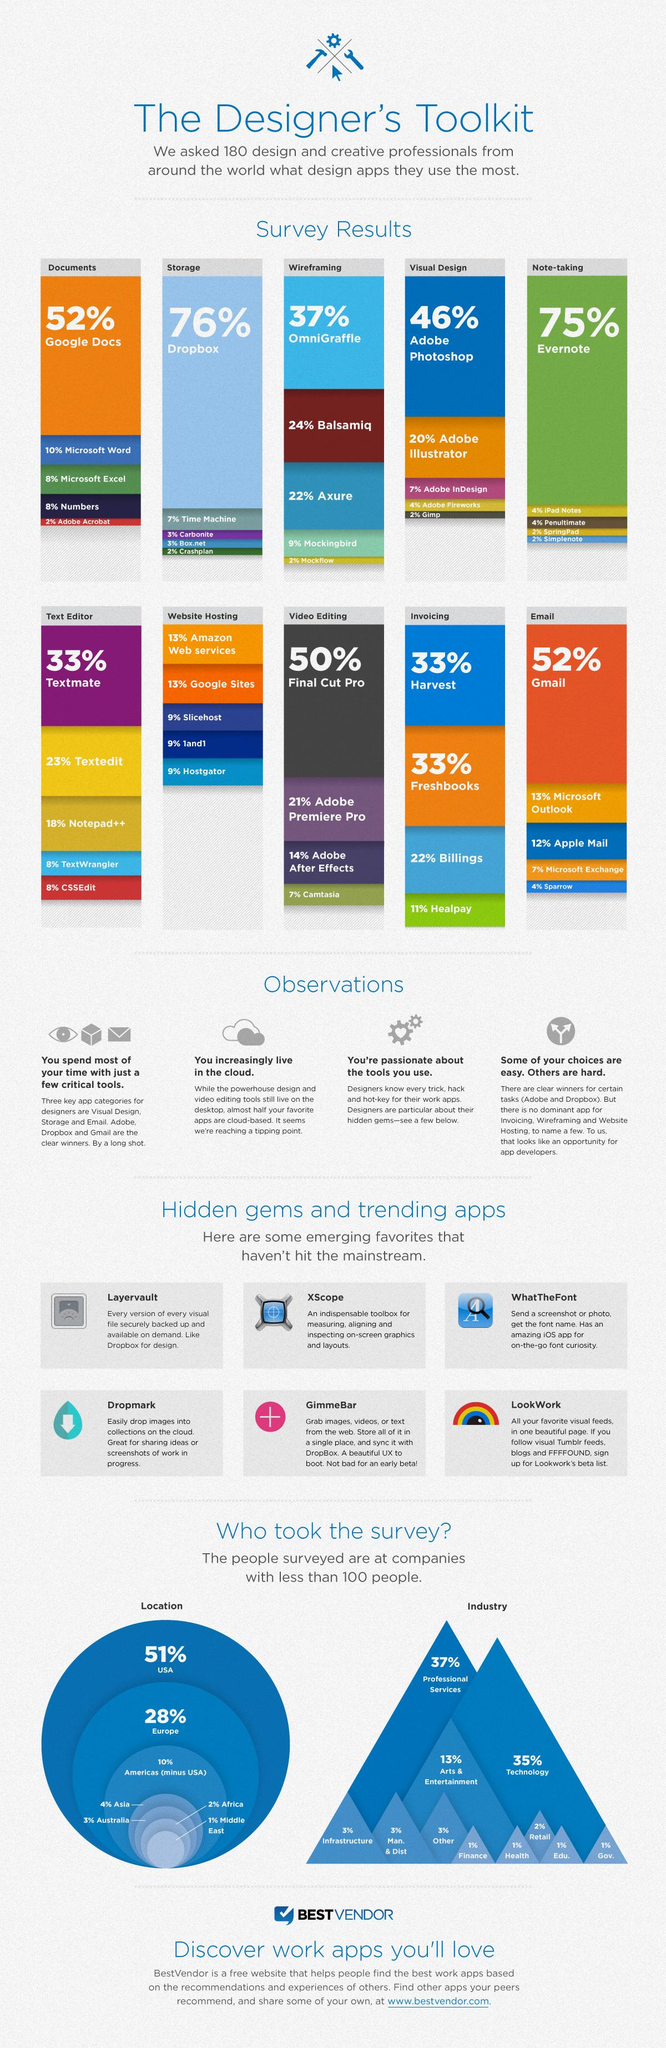Mention a couple of crucial points in this snapshot. Illustrator is the second most commonly used app for visual designing among Illustrator, Photoshop, and InDesign. It is estimated that only 3% of designers use Carbonite and Box.net for storage. Most designers who have taken the Designer Toolkit Survey from industries such as infrastructure and manufacturing have reported a low percentage of 3%. Two of the most widely used apps for invoicing are Harvest and Freshbooks. According to recent data, only 2% of designers are utilizing Adobe Acrobat, Mock Flow, or Gimp. 